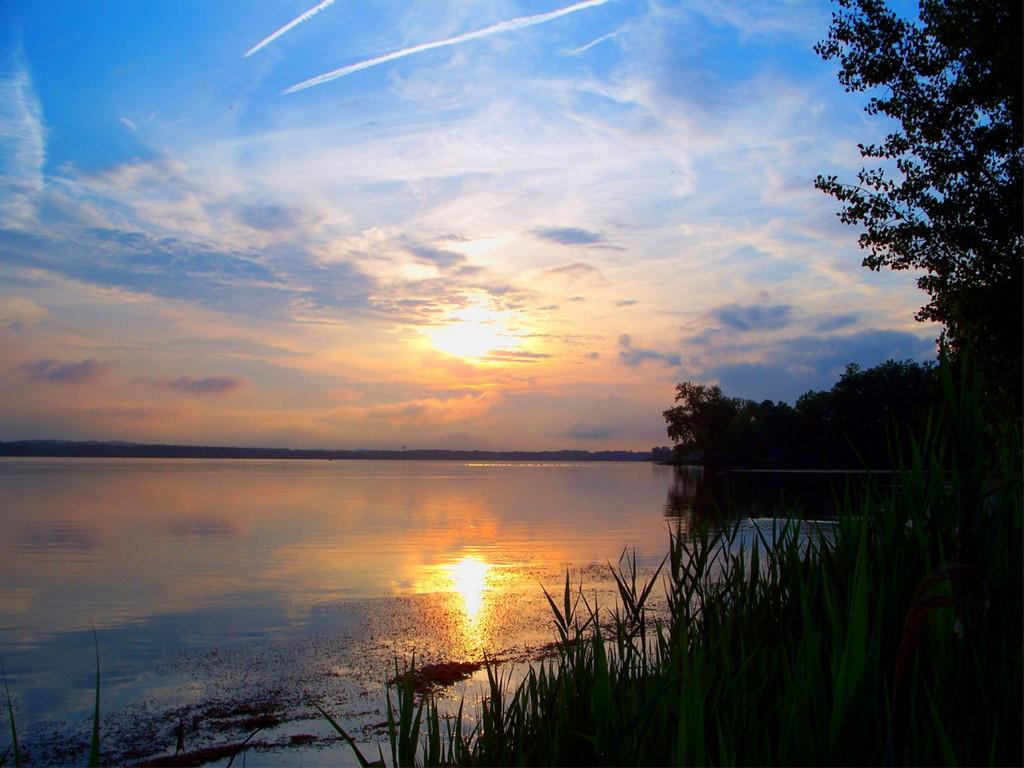What natural feature is present in the image? There is a river in the image. What can be seen in the background of the image? The sky is visible in the background of the image. What celestial body is observable in the sky? The sun is observable in the sky. What type of vegetation is on the right side of the image? There are trees and plants on the right side of the image. What type of music can be heard coming from the river in the image? There is no music present in the image; it is a natural scene featuring a river, sky, sun, and vegetation. 